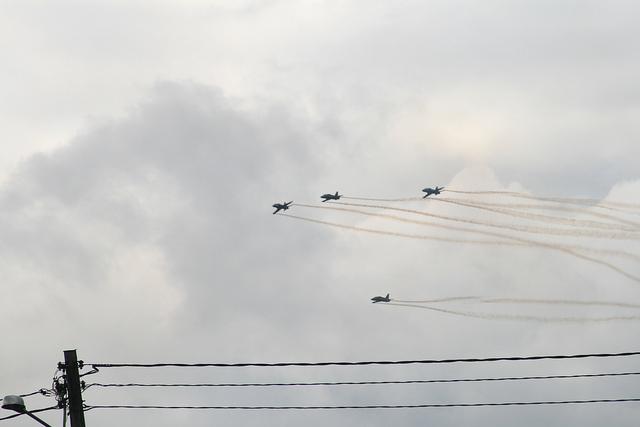What is on the wires?
Answer briefly. Nothing. Are these commercial planes?
Short answer required. No. How many wires are there?
Keep it brief. 3. Are their propellers on the object flying through the sky in this picture?
Give a very brief answer. No. How many wires are attached to the pole?
Answer briefly. 3. What are these aircraft doing together?
Concise answer only. Flying. 